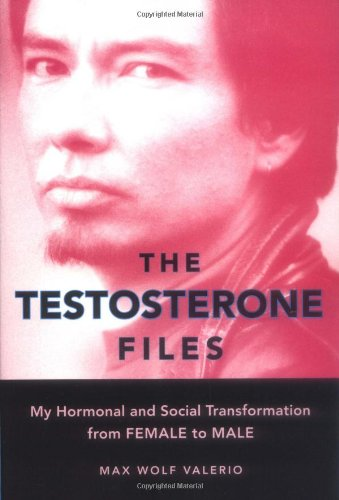Is this book related to Christian Books & Bibles? No, this book does not explore themes directly related to Christianity or the Bible; it focuses more on gender identity and personal transformation. 